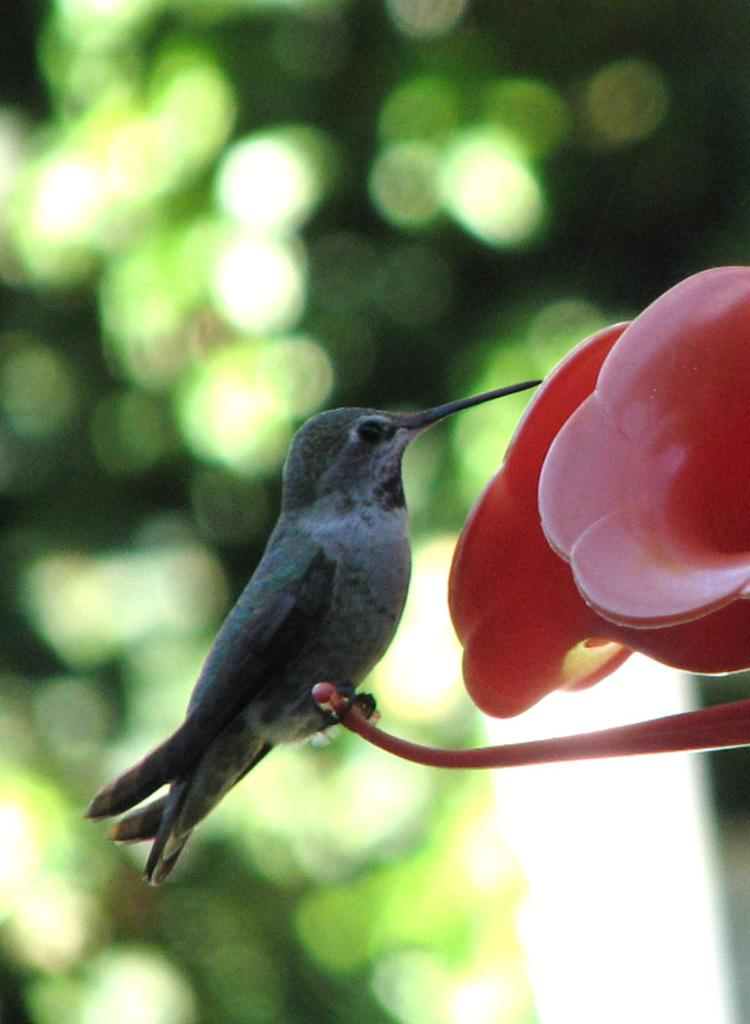What is the main subject in the middle of the image? There is a bird in the middle of the image. What objects are in front of the bird? There are two plastic flowers in front of the bird. What type of vegetation can be seen in the background of the image? There are green leaves in the background of the image. What type of veil is draped over the bird in the image? There is no veil present in the image; the bird is not covered by any fabric or material. 